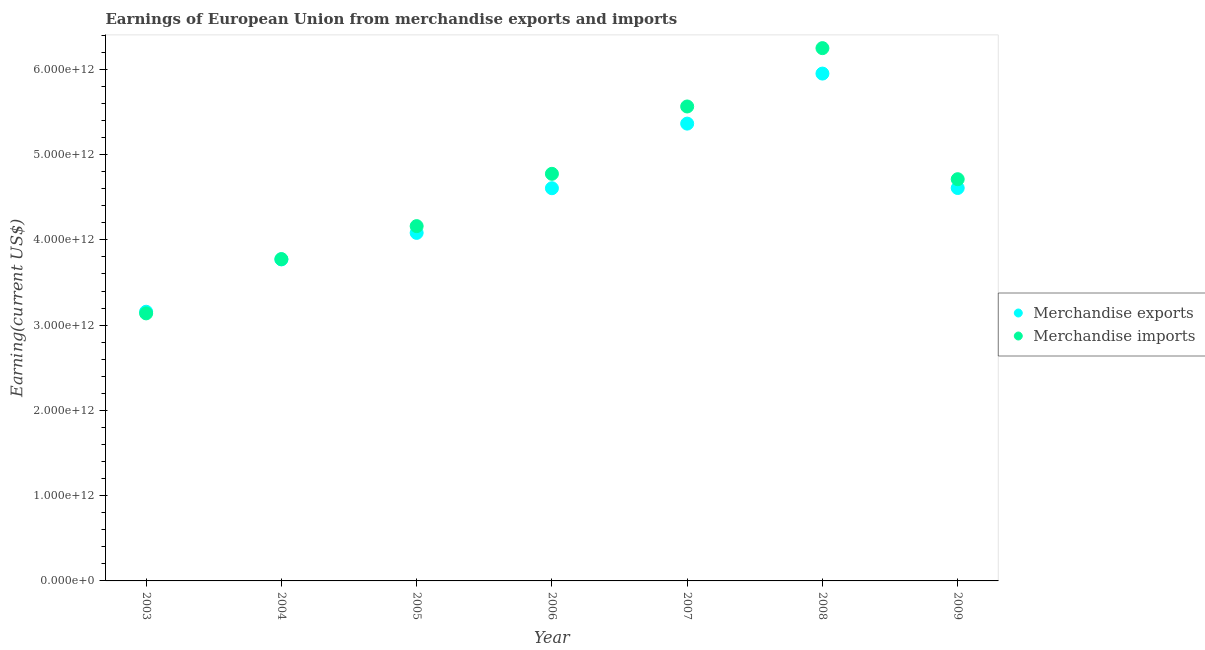What is the earnings from merchandise exports in 2009?
Offer a terse response. 4.61e+12. Across all years, what is the maximum earnings from merchandise exports?
Provide a short and direct response. 5.95e+12. Across all years, what is the minimum earnings from merchandise exports?
Your answer should be very brief. 3.16e+12. In which year was the earnings from merchandise imports maximum?
Offer a terse response. 2008. What is the total earnings from merchandise exports in the graph?
Provide a short and direct response. 3.15e+13. What is the difference between the earnings from merchandise exports in 2004 and that in 2006?
Keep it short and to the point. -8.35e+11. What is the difference between the earnings from merchandise exports in 2004 and the earnings from merchandise imports in 2009?
Keep it short and to the point. -9.41e+11. What is the average earnings from merchandise exports per year?
Offer a terse response. 4.51e+12. In the year 2009, what is the difference between the earnings from merchandise exports and earnings from merchandise imports?
Keep it short and to the point. -1.03e+11. In how many years, is the earnings from merchandise imports greater than 2000000000000 US$?
Provide a succinct answer. 7. What is the ratio of the earnings from merchandise imports in 2003 to that in 2008?
Provide a short and direct response. 0.5. Is the earnings from merchandise imports in 2004 less than that in 2009?
Provide a short and direct response. Yes. Is the difference between the earnings from merchandise imports in 2006 and 2007 greater than the difference between the earnings from merchandise exports in 2006 and 2007?
Your answer should be very brief. No. What is the difference between the highest and the second highest earnings from merchandise exports?
Ensure brevity in your answer.  5.87e+11. What is the difference between the highest and the lowest earnings from merchandise exports?
Provide a succinct answer. 2.79e+12. In how many years, is the earnings from merchandise exports greater than the average earnings from merchandise exports taken over all years?
Provide a short and direct response. 4. Is the sum of the earnings from merchandise imports in 2004 and 2009 greater than the maximum earnings from merchandise exports across all years?
Your answer should be compact. Yes. Does the earnings from merchandise exports monotonically increase over the years?
Provide a succinct answer. No. Is the earnings from merchandise exports strictly less than the earnings from merchandise imports over the years?
Offer a very short reply. No. How many dotlines are there?
Ensure brevity in your answer.  2. How many years are there in the graph?
Make the answer very short. 7. What is the difference between two consecutive major ticks on the Y-axis?
Provide a succinct answer. 1.00e+12. Are the values on the major ticks of Y-axis written in scientific E-notation?
Provide a succinct answer. Yes. Does the graph contain any zero values?
Your answer should be compact. No. Does the graph contain grids?
Your response must be concise. No. How are the legend labels stacked?
Your response must be concise. Vertical. What is the title of the graph?
Your answer should be very brief. Earnings of European Union from merchandise exports and imports. Does "All education staff compensation" appear as one of the legend labels in the graph?
Your answer should be compact. No. What is the label or title of the X-axis?
Offer a very short reply. Year. What is the label or title of the Y-axis?
Your answer should be compact. Earning(current US$). What is the Earning(current US$) in Merchandise exports in 2003?
Ensure brevity in your answer.  3.16e+12. What is the Earning(current US$) of Merchandise imports in 2003?
Your answer should be compact. 3.14e+12. What is the Earning(current US$) in Merchandise exports in 2004?
Give a very brief answer. 3.77e+12. What is the Earning(current US$) in Merchandise imports in 2004?
Ensure brevity in your answer.  3.77e+12. What is the Earning(current US$) of Merchandise exports in 2005?
Your answer should be very brief. 4.08e+12. What is the Earning(current US$) of Merchandise imports in 2005?
Offer a very short reply. 4.16e+12. What is the Earning(current US$) of Merchandise exports in 2006?
Your answer should be compact. 4.61e+12. What is the Earning(current US$) of Merchandise imports in 2006?
Ensure brevity in your answer.  4.77e+12. What is the Earning(current US$) in Merchandise exports in 2007?
Your answer should be very brief. 5.36e+12. What is the Earning(current US$) in Merchandise imports in 2007?
Provide a short and direct response. 5.56e+12. What is the Earning(current US$) of Merchandise exports in 2008?
Your answer should be compact. 5.95e+12. What is the Earning(current US$) in Merchandise imports in 2008?
Offer a terse response. 6.25e+12. What is the Earning(current US$) in Merchandise exports in 2009?
Offer a very short reply. 4.61e+12. What is the Earning(current US$) of Merchandise imports in 2009?
Offer a very short reply. 4.71e+12. Across all years, what is the maximum Earning(current US$) of Merchandise exports?
Your answer should be compact. 5.95e+12. Across all years, what is the maximum Earning(current US$) in Merchandise imports?
Your response must be concise. 6.25e+12. Across all years, what is the minimum Earning(current US$) in Merchandise exports?
Provide a succinct answer. 3.16e+12. Across all years, what is the minimum Earning(current US$) of Merchandise imports?
Provide a short and direct response. 3.14e+12. What is the total Earning(current US$) in Merchandise exports in the graph?
Provide a short and direct response. 3.15e+13. What is the total Earning(current US$) in Merchandise imports in the graph?
Your answer should be compact. 3.24e+13. What is the difference between the Earning(current US$) in Merchandise exports in 2003 and that in 2004?
Provide a short and direct response. -6.14e+11. What is the difference between the Earning(current US$) of Merchandise imports in 2003 and that in 2004?
Offer a terse response. -6.37e+11. What is the difference between the Earning(current US$) of Merchandise exports in 2003 and that in 2005?
Offer a very short reply. -9.25e+11. What is the difference between the Earning(current US$) of Merchandise imports in 2003 and that in 2005?
Your answer should be compact. -1.02e+12. What is the difference between the Earning(current US$) in Merchandise exports in 2003 and that in 2006?
Offer a terse response. -1.45e+12. What is the difference between the Earning(current US$) of Merchandise imports in 2003 and that in 2006?
Offer a very short reply. -1.64e+12. What is the difference between the Earning(current US$) of Merchandise exports in 2003 and that in 2007?
Make the answer very short. -2.21e+12. What is the difference between the Earning(current US$) of Merchandise imports in 2003 and that in 2007?
Ensure brevity in your answer.  -2.43e+12. What is the difference between the Earning(current US$) of Merchandise exports in 2003 and that in 2008?
Give a very brief answer. -2.79e+12. What is the difference between the Earning(current US$) in Merchandise imports in 2003 and that in 2008?
Give a very brief answer. -3.11e+12. What is the difference between the Earning(current US$) in Merchandise exports in 2003 and that in 2009?
Keep it short and to the point. -1.45e+12. What is the difference between the Earning(current US$) in Merchandise imports in 2003 and that in 2009?
Provide a succinct answer. -1.57e+12. What is the difference between the Earning(current US$) of Merchandise exports in 2004 and that in 2005?
Offer a terse response. -3.11e+11. What is the difference between the Earning(current US$) of Merchandise imports in 2004 and that in 2005?
Keep it short and to the point. -3.87e+11. What is the difference between the Earning(current US$) of Merchandise exports in 2004 and that in 2006?
Offer a very short reply. -8.35e+11. What is the difference between the Earning(current US$) in Merchandise imports in 2004 and that in 2006?
Offer a terse response. -1.00e+12. What is the difference between the Earning(current US$) of Merchandise exports in 2004 and that in 2007?
Offer a terse response. -1.59e+12. What is the difference between the Earning(current US$) in Merchandise imports in 2004 and that in 2007?
Keep it short and to the point. -1.79e+12. What is the difference between the Earning(current US$) in Merchandise exports in 2004 and that in 2008?
Provide a succinct answer. -2.18e+12. What is the difference between the Earning(current US$) in Merchandise imports in 2004 and that in 2008?
Keep it short and to the point. -2.47e+12. What is the difference between the Earning(current US$) in Merchandise exports in 2004 and that in 2009?
Offer a terse response. -8.37e+11. What is the difference between the Earning(current US$) in Merchandise imports in 2004 and that in 2009?
Give a very brief answer. -9.37e+11. What is the difference between the Earning(current US$) of Merchandise exports in 2005 and that in 2006?
Offer a terse response. -5.24e+11. What is the difference between the Earning(current US$) of Merchandise imports in 2005 and that in 2006?
Your response must be concise. -6.13e+11. What is the difference between the Earning(current US$) of Merchandise exports in 2005 and that in 2007?
Ensure brevity in your answer.  -1.28e+12. What is the difference between the Earning(current US$) of Merchandise imports in 2005 and that in 2007?
Provide a succinct answer. -1.40e+12. What is the difference between the Earning(current US$) in Merchandise exports in 2005 and that in 2008?
Your response must be concise. -1.87e+12. What is the difference between the Earning(current US$) in Merchandise imports in 2005 and that in 2008?
Ensure brevity in your answer.  -2.09e+12. What is the difference between the Earning(current US$) in Merchandise exports in 2005 and that in 2009?
Your answer should be very brief. -5.26e+11. What is the difference between the Earning(current US$) in Merchandise imports in 2005 and that in 2009?
Offer a very short reply. -5.50e+11. What is the difference between the Earning(current US$) of Merchandise exports in 2006 and that in 2007?
Your answer should be compact. -7.58e+11. What is the difference between the Earning(current US$) of Merchandise imports in 2006 and that in 2007?
Provide a succinct answer. -7.90e+11. What is the difference between the Earning(current US$) of Merchandise exports in 2006 and that in 2008?
Provide a succinct answer. -1.34e+12. What is the difference between the Earning(current US$) in Merchandise imports in 2006 and that in 2008?
Your answer should be very brief. -1.47e+12. What is the difference between the Earning(current US$) of Merchandise exports in 2006 and that in 2009?
Ensure brevity in your answer.  -2.45e+09. What is the difference between the Earning(current US$) of Merchandise imports in 2006 and that in 2009?
Provide a succinct answer. 6.30e+1. What is the difference between the Earning(current US$) in Merchandise exports in 2007 and that in 2008?
Offer a very short reply. -5.87e+11. What is the difference between the Earning(current US$) of Merchandise imports in 2007 and that in 2008?
Your answer should be compact. -6.84e+11. What is the difference between the Earning(current US$) in Merchandise exports in 2007 and that in 2009?
Offer a terse response. 7.55e+11. What is the difference between the Earning(current US$) of Merchandise imports in 2007 and that in 2009?
Your answer should be very brief. 8.53e+11. What is the difference between the Earning(current US$) in Merchandise exports in 2008 and that in 2009?
Ensure brevity in your answer.  1.34e+12. What is the difference between the Earning(current US$) of Merchandise imports in 2008 and that in 2009?
Give a very brief answer. 1.54e+12. What is the difference between the Earning(current US$) in Merchandise exports in 2003 and the Earning(current US$) in Merchandise imports in 2004?
Offer a very short reply. -6.17e+11. What is the difference between the Earning(current US$) in Merchandise exports in 2003 and the Earning(current US$) in Merchandise imports in 2005?
Provide a short and direct response. -1.00e+12. What is the difference between the Earning(current US$) of Merchandise exports in 2003 and the Earning(current US$) of Merchandise imports in 2006?
Give a very brief answer. -1.62e+12. What is the difference between the Earning(current US$) of Merchandise exports in 2003 and the Earning(current US$) of Merchandise imports in 2007?
Your answer should be very brief. -2.41e+12. What is the difference between the Earning(current US$) in Merchandise exports in 2003 and the Earning(current US$) in Merchandise imports in 2008?
Offer a very short reply. -3.09e+12. What is the difference between the Earning(current US$) in Merchandise exports in 2003 and the Earning(current US$) in Merchandise imports in 2009?
Ensure brevity in your answer.  -1.55e+12. What is the difference between the Earning(current US$) of Merchandise exports in 2004 and the Earning(current US$) of Merchandise imports in 2005?
Offer a very short reply. -3.90e+11. What is the difference between the Earning(current US$) in Merchandise exports in 2004 and the Earning(current US$) in Merchandise imports in 2006?
Offer a very short reply. -1.00e+12. What is the difference between the Earning(current US$) of Merchandise exports in 2004 and the Earning(current US$) of Merchandise imports in 2007?
Provide a succinct answer. -1.79e+12. What is the difference between the Earning(current US$) in Merchandise exports in 2004 and the Earning(current US$) in Merchandise imports in 2008?
Your answer should be very brief. -2.48e+12. What is the difference between the Earning(current US$) in Merchandise exports in 2004 and the Earning(current US$) in Merchandise imports in 2009?
Offer a very short reply. -9.41e+11. What is the difference between the Earning(current US$) in Merchandise exports in 2005 and the Earning(current US$) in Merchandise imports in 2006?
Provide a short and direct response. -6.93e+11. What is the difference between the Earning(current US$) in Merchandise exports in 2005 and the Earning(current US$) in Merchandise imports in 2007?
Offer a very short reply. -1.48e+12. What is the difference between the Earning(current US$) in Merchandise exports in 2005 and the Earning(current US$) in Merchandise imports in 2008?
Your response must be concise. -2.17e+12. What is the difference between the Earning(current US$) in Merchandise exports in 2005 and the Earning(current US$) in Merchandise imports in 2009?
Ensure brevity in your answer.  -6.30e+11. What is the difference between the Earning(current US$) of Merchandise exports in 2006 and the Earning(current US$) of Merchandise imports in 2007?
Provide a short and direct response. -9.59e+11. What is the difference between the Earning(current US$) of Merchandise exports in 2006 and the Earning(current US$) of Merchandise imports in 2008?
Provide a succinct answer. -1.64e+12. What is the difference between the Earning(current US$) of Merchandise exports in 2006 and the Earning(current US$) of Merchandise imports in 2009?
Your answer should be compact. -1.06e+11. What is the difference between the Earning(current US$) in Merchandise exports in 2007 and the Earning(current US$) in Merchandise imports in 2008?
Your answer should be very brief. -8.85e+11. What is the difference between the Earning(current US$) in Merchandise exports in 2007 and the Earning(current US$) in Merchandise imports in 2009?
Offer a very short reply. 6.52e+11. What is the difference between the Earning(current US$) in Merchandise exports in 2008 and the Earning(current US$) in Merchandise imports in 2009?
Offer a very short reply. 1.24e+12. What is the average Earning(current US$) of Merchandise exports per year?
Provide a short and direct response. 4.51e+12. What is the average Earning(current US$) of Merchandise imports per year?
Ensure brevity in your answer.  4.62e+12. In the year 2003, what is the difference between the Earning(current US$) of Merchandise exports and Earning(current US$) of Merchandise imports?
Make the answer very short. 1.92e+1. In the year 2004, what is the difference between the Earning(current US$) of Merchandise exports and Earning(current US$) of Merchandise imports?
Offer a terse response. -3.79e+09. In the year 2005, what is the difference between the Earning(current US$) in Merchandise exports and Earning(current US$) in Merchandise imports?
Ensure brevity in your answer.  -7.92e+1. In the year 2006, what is the difference between the Earning(current US$) of Merchandise exports and Earning(current US$) of Merchandise imports?
Your response must be concise. -1.69e+11. In the year 2007, what is the difference between the Earning(current US$) of Merchandise exports and Earning(current US$) of Merchandise imports?
Offer a terse response. -2.01e+11. In the year 2008, what is the difference between the Earning(current US$) of Merchandise exports and Earning(current US$) of Merchandise imports?
Ensure brevity in your answer.  -2.98e+11. In the year 2009, what is the difference between the Earning(current US$) of Merchandise exports and Earning(current US$) of Merchandise imports?
Make the answer very short. -1.03e+11. What is the ratio of the Earning(current US$) in Merchandise exports in 2003 to that in 2004?
Offer a terse response. 0.84. What is the ratio of the Earning(current US$) of Merchandise imports in 2003 to that in 2004?
Ensure brevity in your answer.  0.83. What is the ratio of the Earning(current US$) in Merchandise exports in 2003 to that in 2005?
Provide a short and direct response. 0.77. What is the ratio of the Earning(current US$) of Merchandise imports in 2003 to that in 2005?
Offer a very short reply. 0.75. What is the ratio of the Earning(current US$) of Merchandise exports in 2003 to that in 2006?
Keep it short and to the point. 0.69. What is the ratio of the Earning(current US$) of Merchandise imports in 2003 to that in 2006?
Make the answer very short. 0.66. What is the ratio of the Earning(current US$) in Merchandise exports in 2003 to that in 2007?
Your answer should be compact. 0.59. What is the ratio of the Earning(current US$) of Merchandise imports in 2003 to that in 2007?
Provide a succinct answer. 0.56. What is the ratio of the Earning(current US$) of Merchandise exports in 2003 to that in 2008?
Keep it short and to the point. 0.53. What is the ratio of the Earning(current US$) in Merchandise imports in 2003 to that in 2008?
Offer a very short reply. 0.5. What is the ratio of the Earning(current US$) of Merchandise exports in 2003 to that in 2009?
Provide a succinct answer. 0.69. What is the ratio of the Earning(current US$) of Merchandise imports in 2003 to that in 2009?
Your answer should be very brief. 0.67. What is the ratio of the Earning(current US$) of Merchandise exports in 2004 to that in 2005?
Offer a very short reply. 0.92. What is the ratio of the Earning(current US$) of Merchandise imports in 2004 to that in 2005?
Keep it short and to the point. 0.91. What is the ratio of the Earning(current US$) in Merchandise exports in 2004 to that in 2006?
Offer a terse response. 0.82. What is the ratio of the Earning(current US$) of Merchandise imports in 2004 to that in 2006?
Ensure brevity in your answer.  0.79. What is the ratio of the Earning(current US$) in Merchandise exports in 2004 to that in 2007?
Provide a succinct answer. 0.7. What is the ratio of the Earning(current US$) of Merchandise imports in 2004 to that in 2007?
Keep it short and to the point. 0.68. What is the ratio of the Earning(current US$) of Merchandise exports in 2004 to that in 2008?
Provide a succinct answer. 0.63. What is the ratio of the Earning(current US$) in Merchandise imports in 2004 to that in 2008?
Your answer should be very brief. 0.6. What is the ratio of the Earning(current US$) of Merchandise exports in 2004 to that in 2009?
Ensure brevity in your answer.  0.82. What is the ratio of the Earning(current US$) of Merchandise imports in 2004 to that in 2009?
Your answer should be compact. 0.8. What is the ratio of the Earning(current US$) in Merchandise exports in 2005 to that in 2006?
Make the answer very short. 0.89. What is the ratio of the Earning(current US$) in Merchandise imports in 2005 to that in 2006?
Ensure brevity in your answer.  0.87. What is the ratio of the Earning(current US$) of Merchandise exports in 2005 to that in 2007?
Your answer should be very brief. 0.76. What is the ratio of the Earning(current US$) of Merchandise imports in 2005 to that in 2007?
Offer a terse response. 0.75. What is the ratio of the Earning(current US$) of Merchandise exports in 2005 to that in 2008?
Provide a succinct answer. 0.69. What is the ratio of the Earning(current US$) in Merchandise imports in 2005 to that in 2008?
Provide a succinct answer. 0.67. What is the ratio of the Earning(current US$) in Merchandise exports in 2005 to that in 2009?
Provide a succinct answer. 0.89. What is the ratio of the Earning(current US$) of Merchandise imports in 2005 to that in 2009?
Provide a short and direct response. 0.88. What is the ratio of the Earning(current US$) of Merchandise exports in 2006 to that in 2007?
Keep it short and to the point. 0.86. What is the ratio of the Earning(current US$) in Merchandise imports in 2006 to that in 2007?
Offer a very short reply. 0.86. What is the ratio of the Earning(current US$) of Merchandise exports in 2006 to that in 2008?
Give a very brief answer. 0.77. What is the ratio of the Earning(current US$) of Merchandise imports in 2006 to that in 2008?
Your response must be concise. 0.76. What is the ratio of the Earning(current US$) of Merchandise imports in 2006 to that in 2009?
Offer a terse response. 1.01. What is the ratio of the Earning(current US$) in Merchandise exports in 2007 to that in 2008?
Offer a terse response. 0.9. What is the ratio of the Earning(current US$) of Merchandise imports in 2007 to that in 2008?
Provide a short and direct response. 0.89. What is the ratio of the Earning(current US$) in Merchandise exports in 2007 to that in 2009?
Keep it short and to the point. 1.16. What is the ratio of the Earning(current US$) in Merchandise imports in 2007 to that in 2009?
Provide a succinct answer. 1.18. What is the ratio of the Earning(current US$) of Merchandise exports in 2008 to that in 2009?
Make the answer very short. 1.29. What is the ratio of the Earning(current US$) of Merchandise imports in 2008 to that in 2009?
Your answer should be compact. 1.33. What is the difference between the highest and the second highest Earning(current US$) of Merchandise exports?
Make the answer very short. 5.87e+11. What is the difference between the highest and the second highest Earning(current US$) of Merchandise imports?
Offer a very short reply. 6.84e+11. What is the difference between the highest and the lowest Earning(current US$) in Merchandise exports?
Offer a very short reply. 2.79e+12. What is the difference between the highest and the lowest Earning(current US$) of Merchandise imports?
Provide a succinct answer. 3.11e+12. 